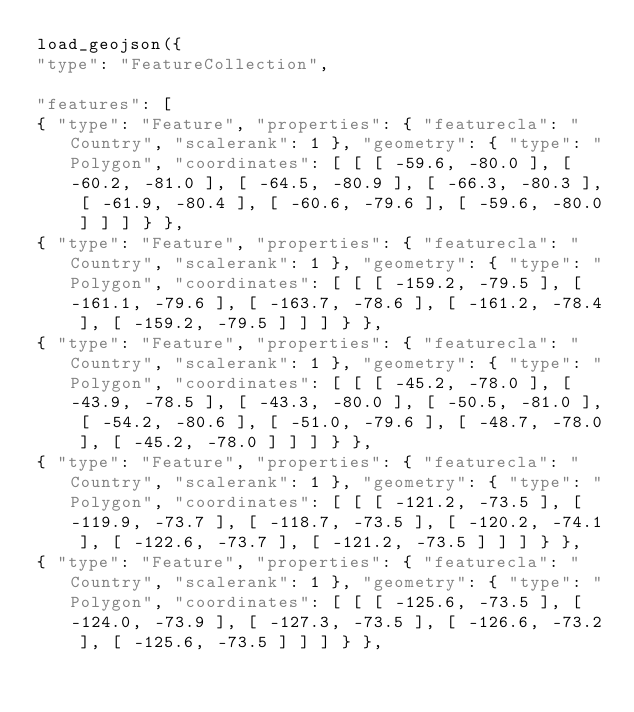<code> <loc_0><loc_0><loc_500><loc_500><_JavaScript_>load_geojson({
"type": "FeatureCollection",

"features": [
{ "type": "Feature", "properties": { "featurecla": "Country", "scalerank": 1 }, "geometry": { "type": "Polygon", "coordinates": [ [ [ -59.6, -80.0 ], [ -60.2, -81.0 ], [ -64.5, -80.9 ], [ -66.3, -80.3 ], [ -61.9, -80.4 ], [ -60.6, -79.6 ], [ -59.6, -80.0 ] ] ] } },
{ "type": "Feature", "properties": { "featurecla": "Country", "scalerank": 1 }, "geometry": { "type": "Polygon", "coordinates": [ [ [ -159.2, -79.5 ], [ -161.1, -79.6 ], [ -163.7, -78.6 ], [ -161.2, -78.4 ], [ -159.2, -79.5 ] ] ] } },
{ "type": "Feature", "properties": { "featurecla": "Country", "scalerank": 1 }, "geometry": { "type": "Polygon", "coordinates": [ [ [ -45.2, -78.0 ], [ -43.9, -78.5 ], [ -43.3, -80.0 ], [ -50.5, -81.0 ], [ -54.2, -80.6 ], [ -51.0, -79.6 ], [ -48.7, -78.0 ], [ -45.2, -78.0 ] ] ] } },
{ "type": "Feature", "properties": { "featurecla": "Country", "scalerank": 1 }, "geometry": { "type": "Polygon", "coordinates": [ [ [ -121.2, -73.5 ], [ -119.9, -73.7 ], [ -118.7, -73.5 ], [ -120.2, -74.1 ], [ -122.6, -73.7 ], [ -121.2, -73.5 ] ] ] } },
{ "type": "Feature", "properties": { "featurecla": "Country", "scalerank": 1 }, "geometry": { "type": "Polygon", "coordinates": [ [ [ -125.6, -73.5 ], [ -124.0, -73.9 ], [ -127.3, -73.5 ], [ -126.6, -73.2 ], [ -125.6, -73.5 ] ] ] } },</code> 